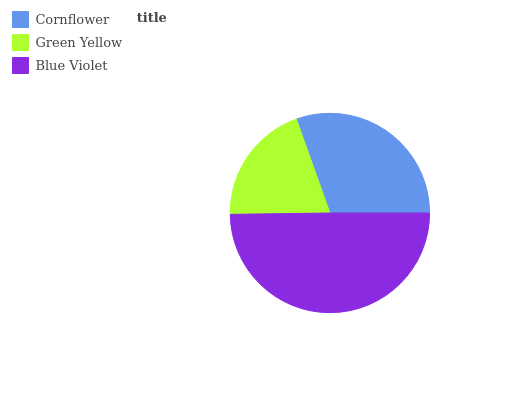Is Green Yellow the minimum?
Answer yes or no. Yes. Is Blue Violet the maximum?
Answer yes or no. Yes. Is Blue Violet the minimum?
Answer yes or no. No. Is Green Yellow the maximum?
Answer yes or no. No. Is Blue Violet greater than Green Yellow?
Answer yes or no. Yes. Is Green Yellow less than Blue Violet?
Answer yes or no. Yes. Is Green Yellow greater than Blue Violet?
Answer yes or no. No. Is Blue Violet less than Green Yellow?
Answer yes or no. No. Is Cornflower the high median?
Answer yes or no. Yes. Is Cornflower the low median?
Answer yes or no. Yes. Is Green Yellow the high median?
Answer yes or no. No. Is Green Yellow the low median?
Answer yes or no. No. 